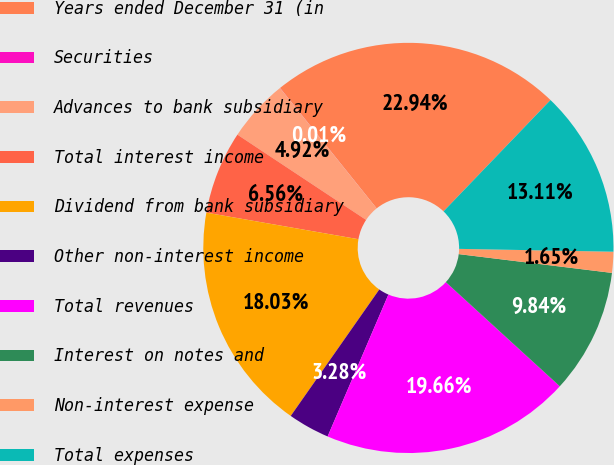Convert chart. <chart><loc_0><loc_0><loc_500><loc_500><pie_chart><fcel>Years ended December 31 (in<fcel>Securities<fcel>Advances to bank subsidiary<fcel>Total interest income<fcel>Dividend from bank subsidiary<fcel>Other non-interest income<fcel>Total revenues<fcel>Interest on notes and<fcel>Non-interest expense<fcel>Total expenses<nl><fcel>22.94%<fcel>0.01%<fcel>4.92%<fcel>6.56%<fcel>18.03%<fcel>3.28%<fcel>19.66%<fcel>9.84%<fcel>1.65%<fcel>13.11%<nl></chart> 